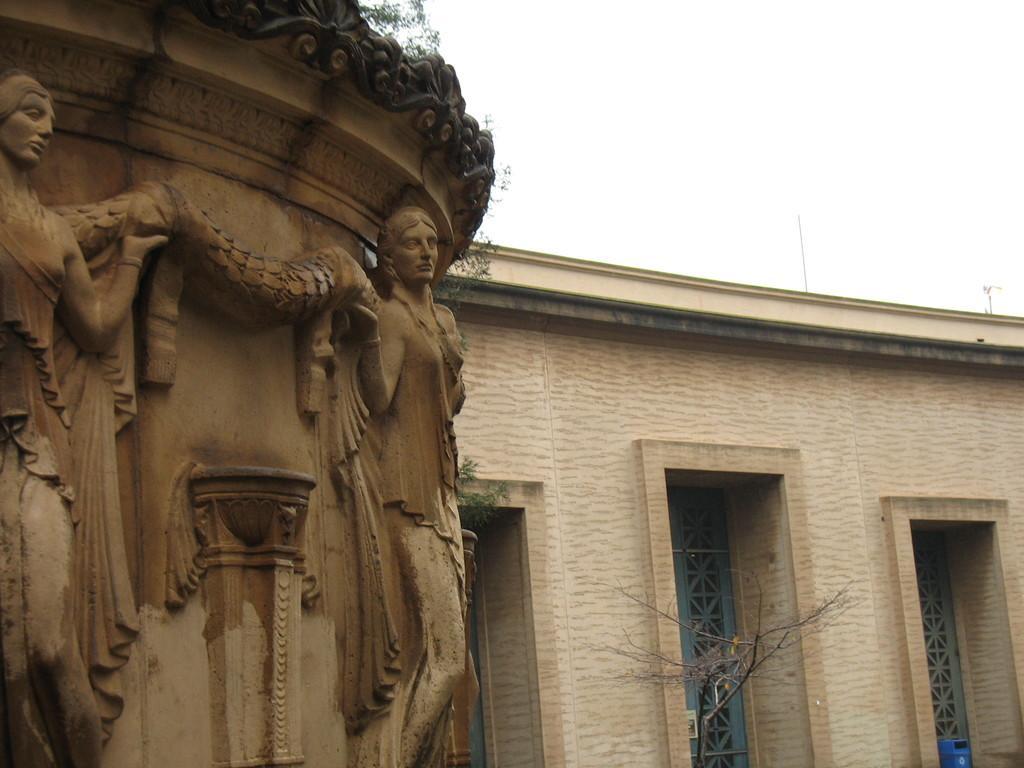Could you give a brief overview of what you see in this image? This picture shows a building and we see sculpture on the wall and we see a tree. 